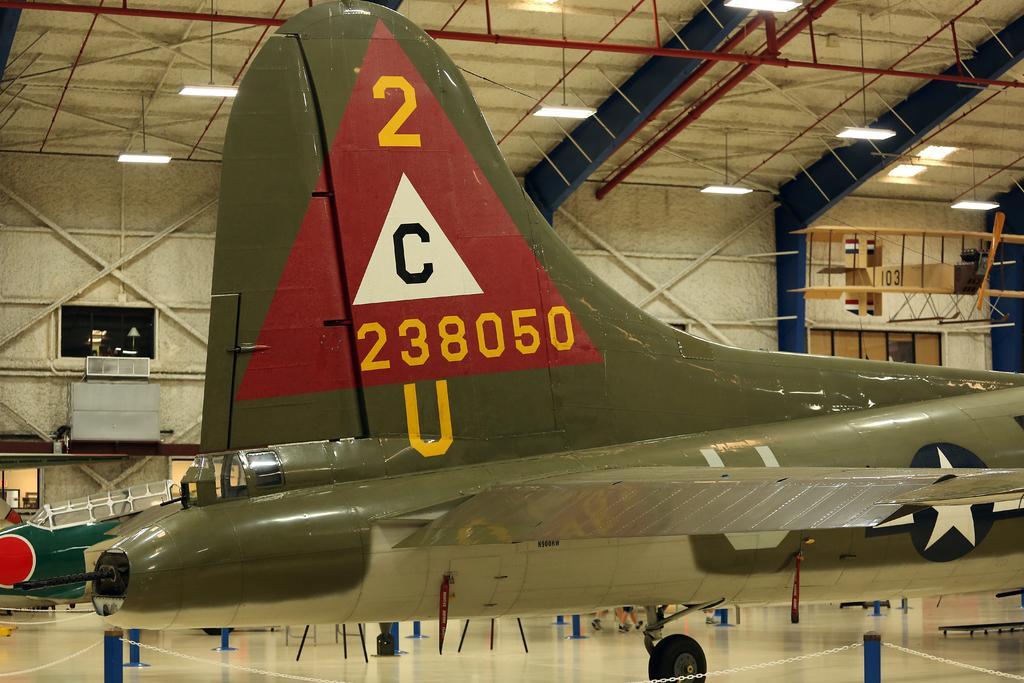<image>
Provide a brief description of the given image. A fighter plane is in a hanger and has the tail number 238050. 